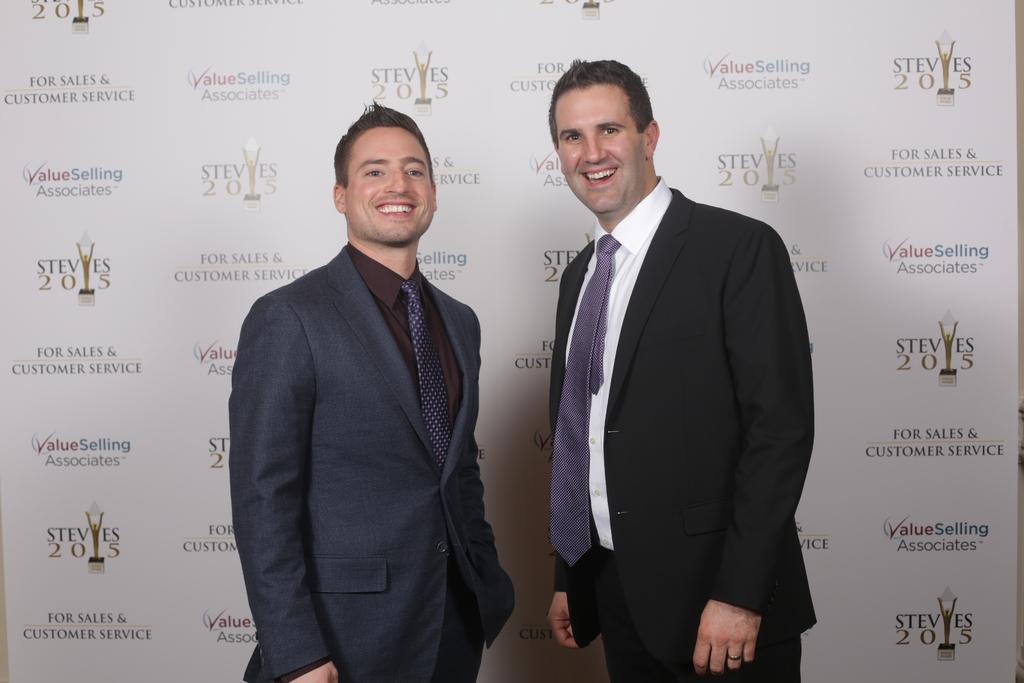Please provide a concise description of this image. In the image there are two men, they are standing and laughing, behind them there is a banner and on the banner there are some names of the companies. 